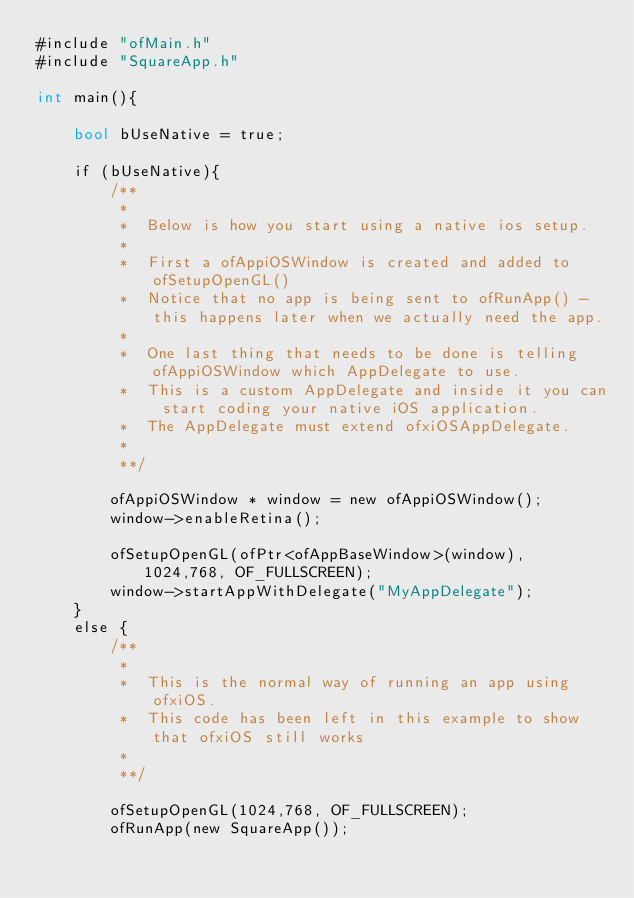Convert code to text. <code><loc_0><loc_0><loc_500><loc_500><_ObjectiveC_>#include "ofMain.h"
#include "SquareApp.h"

int main(){

    bool bUseNative = true;
    
    if (bUseNative){
        /**
         *
         *  Below is how you start using a native ios setup.
         *
         *  First a ofAppiOSWindow is created and added to ofSetupOpenGL()
         *  Notice that no app is being sent to ofRunApp() - this happens later when we actually need the app.
         *
         *  One last thing that needs to be done is telling ofAppiOSWindow which AppDelegate to use.
         *  This is a custom AppDelegate and inside it you can start coding your native iOS application.
         *  The AppDelegate must extend ofxiOSAppDelegate.
         *
         **/
        
        ofAppiOSWindow * window = new ofAppiOSWindow();
        window->enableRetina();
        
        ofSetupOpenGL(ofPtr<ofAppBaseWindow>(window), 1024,768, OF_FULLSCREEN);
        window->startAppWithDelegate("MyAppDelegate");
    }
    else {
        /**
         *
         *  This is the normal way of running an app using ofxiOS.
         *  This code has been left in this example to show that ofxiOS still works
         *
         **/
        
        ofSetupOpenGL(1024,768, OF_FULLSCREEN);
        ofRunApp(new SquareApp());</code> 